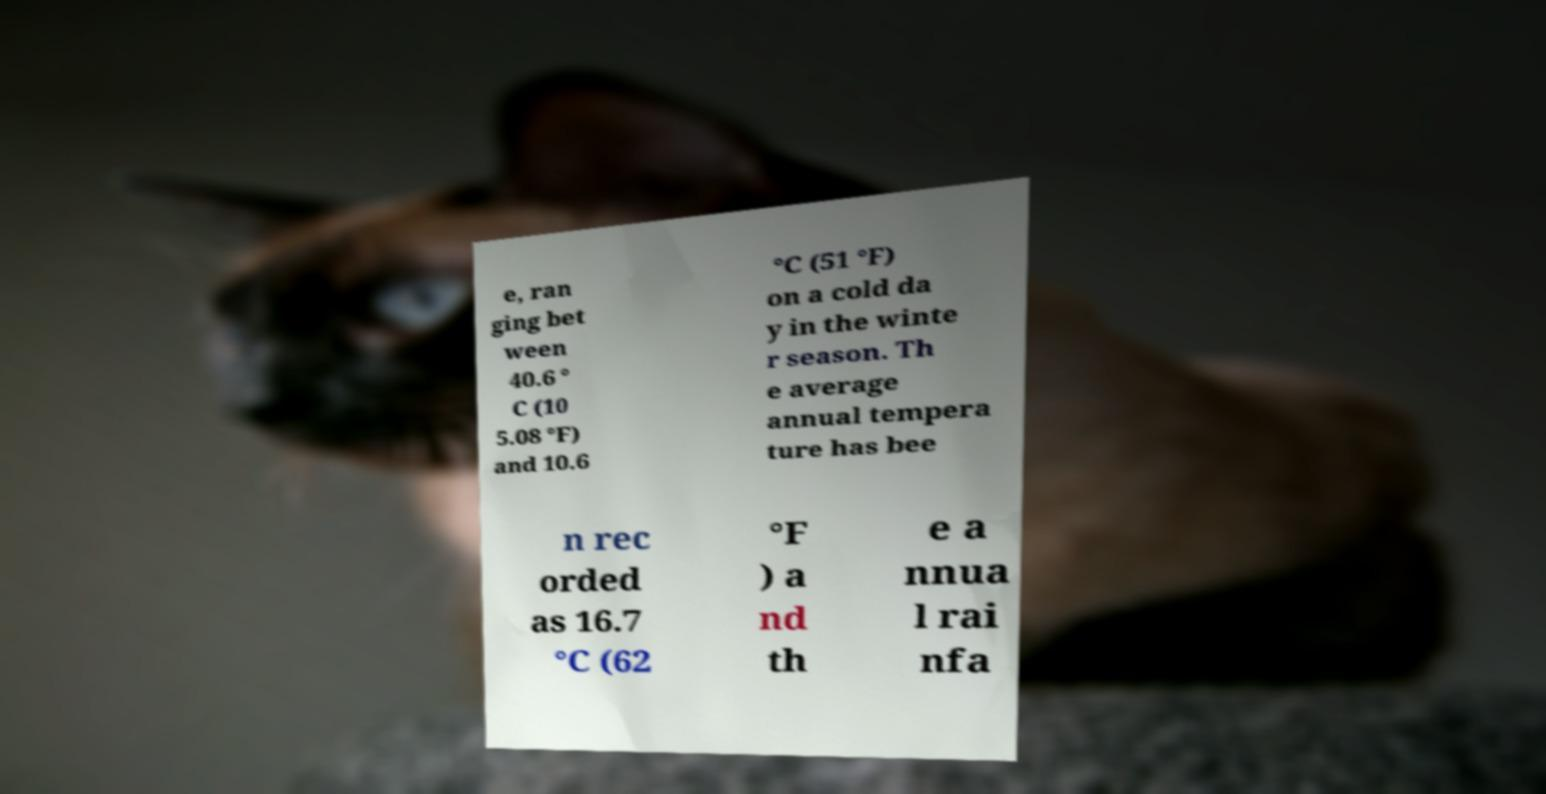Can you read and provide the text displayed in the image?This photo seems to have some interesting text. Can you extract and type it out for me? e, ran ging bet ween 40.6 ° C (10 5.08 °F) and 10.6 °C (51 °F) on a cold da y in the winte r season. Th e average annual tempera ture has bee n rec orded as 16.7 °C (62 °F ) a nd th e a nnua l rai nfa 